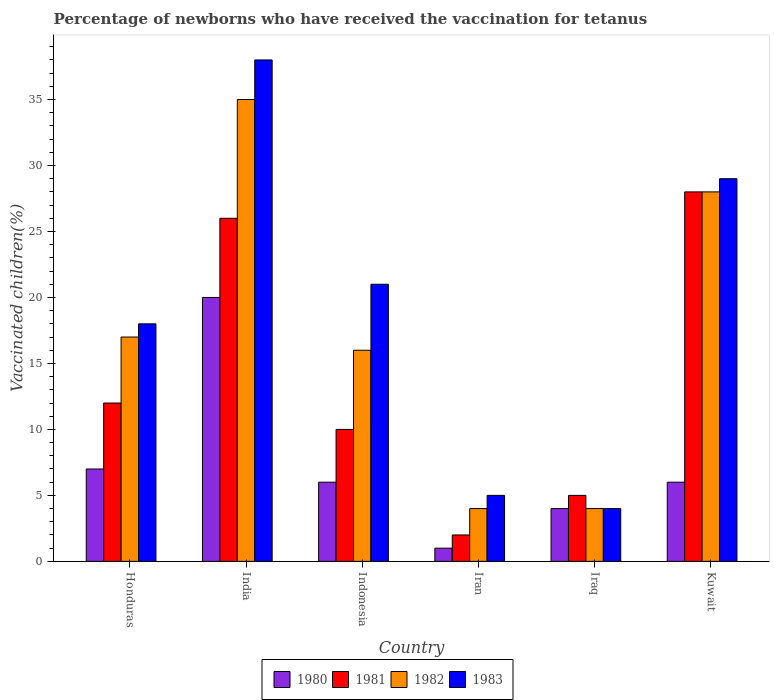Are the number of bars per tick equal to the number of legend labels?
Ensure brevity in your answer.  Yes. What is the label of the 6th group of bars from the left?
Your response must be concise. Kuwait. What is the percentage of vaccinated children in 1983 in Iraq?
Your answer should be compact. 4. Across all countries, what is the minimum percentage of vaccinated children in 1981?
Ensure brevity in your answer.  2. In which country was the percentage of vaccinated children in 1982 maximum?
Your response must be concise. India. In which country was the percentage of vaccinated children in 1980 minimum?
Keep it short and to the point. Iran. What is the total percentage of vaccinated children in 1982 in the graph?
Ensure brevity in your answer.  104. What is the difference between the percentage of vaccinated children in 1982 in Honduras and that in Iraq?
Provide a succinct answer. 13. What is the average percentage of vaccinated children in 1983 per country?
Offer a terse response. 19.17. What is the difference between the percentage of vaccinated children of/in 1982 and percentage of vaccinated children of/in 1981 in Honduras?
Ensure brevity in your answer.  5. In how many countries, is the percentage of vaccinated children in 1983 greater than 17 %?
Ensure brevity in your answer.  4. What is the ratio of the percentage of vaccinated children in 1982 in Iraq to that in Kuwait?
Your answer should be very brief. 0.14. Is the difference between the percentage of vaccinated children in 1982 in Honduras and Kuwait greater than the difference between the percentage of vaccinated children in 1981 in Honduras and Kuwait?
Provide a succinct answer. Yes. What is the difference between the highest and the lowest percentage of vaccinated children in 1983?
Provide a short and direct response. 34. In how many countries, is the percentage of vaccinated children in 1981 greater than the average percentage of vaccinated children in 1981 taken over all countries?
Your answer should be compact. 2. Is it the case that in every country, the sum of the percentage of vaccinated children in 1981 and percentage of vaccinated children in 1983 is greater than the percentage of vaccinated children in 1980?
Your response must be concise. Yes. How many bars are there?
Provide a short and direct response. 24. What is the difference between two consecutive major ticks on the Y-axis?
Offer a terse response. 5. Are the values on the major ticks of Y-axis written in scientific E-notation?
Offer a very short reply. No. What is the title of the graph?
Offer a terse response. Percentage of newborns who have received the vaccination for tetanus. What is the label or title of the Y-axis?
Ensure brevity in your answer.  Vaccinated children(%). What is the Vaccinated children(%) in 1980 in Honduras?
Offer a very short reply. 7. What is the Vaccinated children(%) of 1981 in Honduras?
Provide a succinct answer. 12. What is the Vaccinated children(%) of 1980 in India?
Keep it short and to the point. 20. What is the Vaccinated children(%) in 1980 in Indonesia?
Offer a very short reply. 6. What is the Vaccinated children(%) of 1982 in Indonesia?
Provide a succinct answer. 16. What is the Vaccinated children(%) in 1981 in Iran?
Your answer should be compact. 2. What is the Vaccinated children(%) in 1982 in Iran?
Ensure brevity in your answer.  4. What is the Vaccinated children(%) in 1983 in Iran?
Your response must be concise. 5. What is the Vaccinated children(%) of 1981 in Iraq?
Make the answer very short. 5. What is the Vaccinated children(%) of 1981 in Kuwait?
Make the answer very short. 28. What is the Vaccinated children(%) in 1983 in Kuwait?
Make the answer very short. 29. Across all countries, what is the maximum Vaccinated children(%) in 1980?
Provide a succinct answer. 20. Across all countries, what is the maximum Vaccinated children(%) in 1982?
Offer a terse response. 35. Across all countries, what is the minimum Vaccinated children(%) of 1980?
Your response must be concise. 1. Across all countries, what is the minimum Vaccinated children(%) in 1981?
Your answer should be compact. 2. Across all countries, what is the minimum Vaccinated children(%) of 1983?
Your response must be concise. 4. What is the total Vaccinated children(%) in 1981 in the graph?
Give a very brief answer. 83. What is the total Vaccinated children(%) in 1982 in the graph?
Keep it short and to the point. 104. What is the total Vaccinated children(%) in 1983 in the graph?
Your answer should be very brief. 115. What is the difference between the Vaccinated children(%) in 1981 in Honduras and that in India?
Keep it short and to the point. -14. What is the difference between the Vaccinated children(%) in 1982 in Honduras and that in Indonesia?
Make the answer very short. 1. What is the difference between the Vaccinated children(%) in 1981 in Honduras and that in Iran?
Your answer should be very brief. 10. What is the difference between the Vaccinated children(%) of 1982 in Honduras and that in Iran?
Your answer should be compact. 13. What is the difference between the Vaccinated children(%) of 1980 in Honduras and that in Iraq?
Offer a very short reply. 3. What is the difference between the Vaccinated children(%) of 1981 in Honduras and that in Iraq?
Keep it short and to the point. 7. What is the difference between the Vaccinated children(%) of 1982 in Honduras and that in Iraq?
Offer a very short reply. 13. What is the difference between the Vaccinated children(%) of 1983 in Honduras and that in Iraq?
Ensure brevity in your answer.  14. What is the difference between the Vaccinated children(%) of 1982 in Honduras and that in Kuwait?
Offer a very short reply. -11. What is the difference between the Vaccinated children(%) in 1980 in India and that in Indonesia?
Your response must be concise. 14. What is the difference between the Vaccinated children(%) in 1981 in India and that in Indonesia?
Offer a very short reply. 16. What is the difference between the Vaccinated children(%) of 1980 in India and that in Iran?
Your answer should be compact. 19. What is the difference between the Vaccinated children(%) in 1981 in India and that in Iran?
Your response must be concise. 24. What is the difference between the Vaccinated children(%) in 1983 in India and that in Iran?
Give a very brief answer. 33. What is the difference between the Vaccinated children(%) of 1980 in India and that in Iraq?
Offer a terse response. 16. What is the difference between the Vaccinated children(%) in 1982 in India and that in Iraq?
Your response must be concise. 31. What is the difference between the Vaccinated children(%) of 1983 in India and that in Iraq?
Your response must be concise. 34. What is the difference between the Vaccinated children(%) in 1980 in India and that in Kuwait?
Your answer should be very brief. 14. What is the difference between the Vaccinated children(%) of 1981 in India and that in Kuwait?
Your answer should be very brief. -2. What is the difference between the Vaccinated children(%) of 1983 in Indonesia and that in Iraq?
Keep it short and to the point. 17. What is the difference between the Vaccinated children(%) of 1981 in Indonesia and that in Kuwait?
Provide a short and direct response. -18. What is the difference between the Vaccinated children(%) in 1983 in Indonesia and that in Kuwait?
Offer a terse response. -8. What is the difference between the Vaccinated children(%) of 1980 in Iran and that in Iraq?
Make the answer very short. -3. What is the difference between the Vaccinated children(%) in 1983 in Iran and that in Iraq?
Offer a very short reply. 1. What is the difference between the Vaccinated children(%) in 1982 in Iran and that in Kuwait?
Your answer should be very brief. -24. What is the difference between the Vaccinated children(%) in 1983 in Iran and that in Kuwait?
Ensure brevity in your answer.  -24. What is the difference between the Vaccinated children(%) of 1980 in Iraq and that in Kuwait?
Your response must be concise. -2. What is the difference between the Vaccinated children(%) of 1982 in Iraq and that in Kuwait?
Provide a succinct answer. -24. What is the difference between the Vaccinated children(%) in 1983 in Iraq and that in Kuwait?
Give a very brief answer. -25. What is the difference between the Vaccinated children(%) of 1980 in Honduras and the Vaccinated children(%) of 1982 in India?
Give a very brief answer. -28. What is the difference between the Vaccinated children(%) of 1980 in Honduras and the Vaccinated children(%) of 1983 in India?
Give a very brief answer. -31. What is the difference between the Vaccinated children(%) in 1981 in Honduras and the Vaccinated children(%) in 1983 in India?
Ensure brevity in your answer.  -26. What is the difference between the Vaccinated children(%) in 1982 in Honduras and the Vaccinated children(%) in 1983 in India?
Ensure brevity in your answer.  -21. What is the difference between the Vaccinated children(%) in 1980 in Honduras and the Vaccinated children(%) in 1981 in Indonesia?
Provide a succinct answer. -3. What is the difference between the Vaccinated children(%) in 1980 in Honduras and the Vaccinated children(%) in 1982 in Indonesia?
Offer a very short reply. -9. What is the difference between the Vaccinated children(%) in 1981 in Honduras and the Vaccinated children(%) in 1982 in Indonesia?
Ensure brevity in your answer.  -4. What is the difference between the Vaccinated children(%) in 1981 in Honduras and the Vaccinated children(%) in 1983 in Indonesia?
Your answer should be very brief. -9. What is the difference between the Vaccinated children(%) of 1982 in Honduras and the Vaccinated children(%) of 1983 in Indonesia?
Offer a terse response. -4. What is the difference between the Vaccinated children(%) in 1980 in Honduras and the Vaccinated children(%) in 1983 in Iran?
Provide a succinct answer. 2. What is the difference between the Vaccinated children(%) in 1980 in Honduras and the Vaccinated children(%) in 1981 in Iraq?
Your answer should be compact. 2. What is the difference between the Vaccinated children(%) in 1981 in Honduras and the Vaccinated children(%) in 1982 in Iraq?
Provide a short and direct response. 8. What is the difference between the Vaccinated children(%) of 1981 in Honduras and the Vaccinated children(%) of 1983 in Iraq?
Your response must be concise. 8. What is the difference between the Vaccinated children(%) in 1982 in Honduras and the Vaccinated children(%) in 1983 in Kuwait?
Keep it short and to the point. -12. What is the difference between the Vaccinated children(%) in 1980 in India and the Vaccinated children(%) in 1981 in Indonesia?
Make the answer very short. 10. What is the difference between the Vaccinated children(%) in 1981 in India and the Vaccinated children(%) in 1983 in Indonesia?
Offer a very short reply. 5. What is the difference between the Vaccinated children(%) in 1980 in India and the Vaccinated children(%) in 1982 in Iran?
Your answer should be very brief. 16. What is the difference between the Vaccinated children(%) of 1980 in India and the Vaccinated children(%) of 1983 in Iran?
Your answer should be compact. 15. What is the difference between the Vaccinated children(%) in 1981 in India and the Vaccinated children(%) in 1982 in Iran?
Your response must be concise. 22. What is the difference between the Vaccinated children(%) in 1980 in India and the Vaccinated children(%) in 1981 in Iraq?
Offer a terse response. 15. What is the difference between the Vaccinated children(%) of 1980 in India and the Vaccinated children(%) of 1982 in Iraq?
Make the answer very short. 16. What is the difference between the Vaccinated children(%) of 1981 in India and the Vaccinated children(%) of 1983 in Iraq?
Keep it short and to the point. 22. What is the difference between the Vaccinated children(%) in 1980 in India and the Vaccinated children(%) in 1981 in Kuwait?
Keep it short and to the point. -8. What is the difference between the Vaccinated children(%) in 1980 in India and the Vaccinated children(%) in 1983 in Kuwait?
Your answer should be very brief. -9. What is the difference between the Vaccinated children(%) of 1981 in India and the Vaccinated children(%) of 1982 in Kuwait?
Offer a terse response. -2. What is the difference between the Vaccinated children(%) of 1981 in India and the Vaccinated children(%) of 1983 in Kuwait?
Your answer should be very brief. -3. What is the difference between the Vaccinated children(%) in 1982 in India and the Vaccinated children(%) in 1983 in Kuwait?
Give a very brief answer. 6. What is the difference between the Vaccinated children(%) of 1980 in Indonesia and the Vaccinated children(%) of 1982 in Iran?
Provide a short and direct response. 2. What is the difference between the Vaccinated children(%) in 1980 in Indonesia and the Vaccinated children(%) in 1983 in Iran?
Your answer should be very brief. 1. What is the difference between the Vaccinated children(%) in 1981 in Indonesia and the Vaccinated children(%) in 1982 in Iran?
Your answer should be very brief. 6. What is the difference between the Vaccinated children(%) in 1980 in Indonesia and the Vaccinated children(%) in 1982 in Iraq?
Keep it short and to the point. 2. What is the difference between the Vaccinated children(%) in 1981 in Indonesia and the Vaccinated children(%) in 1982 in Iraq?
Give a very brief answer. 6. What is the difference between the Vaccinated children(%) in 1981 in Indonesia and the Vaccinated children(%) in 1983 in Iraq?
Offer a terse response. 6. What is the difference between the Vaccinated children(%) in 1980 in Indonesia and the Vaccinated children(%) in 1982 in Kuwait?
Provide a short and direct response. -22. What is the difference between the Vaccinated children(%) of 1980 in Indonesia and the Vaccinated children(%) of 1983 in Kuwait?
Offer a terse response. -23. What is the difference between the Vaccinated children(%) in 1982 in Indonesia and the Vaccinated children(%) in 1983 in Kuwait?
Your answer should be compact. -13. What is the difference between the Vaccinated children(%) in 1980 in Iran and the Vaccinated children(%) in 1983 in Iraq?
Ensure brevity in your answer.  -3. What is the difference between the Vaccinated children(%) in 1981 in Iran and the Vaccinated children(%) in 1982 in Iraq?
Ensure brevity in your answer.  -2. What is the difference between the Vaccinated children(%) of 1980 in Iran and the Vaccinated children(%) of 1983 in Kuwait?
Offer a very short reply. -28. What is the difference between the Vaccinated children(%) of 1981 in Iran and the Vaccinated children(%) of 1982 in Kuwait?
Your answer should be compact. -26. What is the difference between the Vaccinated children(%) in 1981 in Iran and the Vaccinated children(%) in 1983 in Kuwait?
Offer a terse response. -27. What is the difference between the Vaccinated children(%) in 1980 in Iraq and the Vaccinated children(%) in 1981 in Kuwait?
Your answer should be compact. -24. What is the difference between the Vaccinated children(%) of 1981 in Iraq and the Vaccinated children(%) of 1982 in Kuwait?
Provide a short and direct response. -23. What is the difference between the Vaccinated children(%) in 1982 in Iraq and the Vaccinated children(%) in 1983 in Kuwait?
Your response must be concise. -25. What is the average Vaccinated children(%) in 1980 per country?
Ensure brevity in your answer.  7.33. What is the average Vaccinated children(%) of 1981 per country?
Offer a terse response. 13.83. What is the average Vaccinated children(%) in 1982 per country?
Provide a succinct answer. 17.33. What is the average Vaccinated children(%) in 1983 per country?
Provide a succinct answer. 19.17. What is the difference between the Vaccinated children(%) in 1980 and Vaccinated children(%) in 1981 in Honduras?
Your answer should be compact. -5. What is the difference between the Vaccinated children(%) in 1980 and Vaccinated children(%) in 1983 in Honduras?
Your answer should be compact. -11. What is the difference between the Vaccinated children(%) of 1981 and Vaccinated children(%) of 1983 in Honduras?
Your answer should be very brief. -6. What is the difference between the Vaccinated children(%) of 1980 and Vaccinated children(%) of 1981 in India?
Keep it short and to the point. -6. What is the difference between the Vaccinated children(%) in 1980 and Vaccinated children(%) in 1982 in India?
Your answer should be compact. -15. What is the difference between the Vaccinated children(%) of 1980 and Vaccinated children(%) of 1983 in India?
Make the answer very short. -18. What is the difference between the Vaccinated children(%) in 1981 and Vaccinated children(%) in 1983 in India?
Give a very brief answer. -12. What is the difference between the Vaccinated children(%) of 1980 and Vaccinated children(%) of 1981 in Indonesia?
Your answer should be very brief. -4. What is the difference between the Vaccinated children(%) in 1980 and Vaccinated children(%) in 1983 in Indonesia?
Give a very brief answer. -15. What is the difference between the Vaccinated children(%) in 1981 and Vaccinated children(%) in 1983 in Indonesia?
Your response must be concise. -11. What is the difference between the Vaccinated children(%) in 1982 and Vaccinated children(%) in 1983 in Indonesia?
Your answer should be very brief. -5. What is the difference between the Vaccinated children(%) in 1980 and Vaccinated children(%) in 1983 in Iran?
Offer a terse response. -4. What is the difference between the Vaccinated children(%) of 1981 and Vaccinated children(%) of 1982 in Iran?
Give a very brief answer. -2. What is the difference between the Vaccinated children(%) of 1980 and Vaccinated children(%) of 1983 in Iraq?
Make the answer very short. 0. What is the difference between the Vaccinated children(%) of 1980 and Vaccinated children(%) of 1981 in Kuwait?
Make the answer very short. -22. What is the difference between the Vaccinated children(%) in 1980 and Vaccinated children(%) in 1982 in Kuwait?
Your answer should be very brief. -22. What is the difference between the Vaccinated children(%) in 1980 and Vaccinated children(%) in 1983 in Kuwait?
Give a very brief answer. -23. What is the difference between the Vaccinated children(%) in 1981 and Vaccinated children(%) in 1982 in Kuwait?
Your answer should be compact. 0. What is the difference between the Vaccinated children(%) of 1981 and Vaccinated children(%) of 1983 in Kuwait?
Your answer should be compact. -1. What is the ratio of the Vaccinated children(%) of 1980 in Honduras to that in India?
Provide a succinct answer. 0.35. What is the ratio of the Vaccinated children(%) in 1981 in Honduras to that in India?
Offer a very short reply. 0.46. What is the ratio of the Vaccinated children(%) of 1982 in Honduras to that in India?
Ensure brevity in your answer.  0.49. What is the ratio of the Vaccinated children(%) of 1983 in Honduras to that in India?
Provide a succinct answer. 0.47. What is the ratio of the Vaccinated children(%) in 1980 in Honduras to that in Indonesia?
Your answer should be compact. 1.17. What is the ratio of the Vaccinated children(%) of 1982 in Honduras to that in Indonesia?
Ensure brevity in your answer.  1.06. What is the ratio of the Vaccinated children(%) in 1983 in Honduras to that in Indonesia?
Offer a very short reply. 0.86. What is the ratio of the Vaccinated children(%) in 1981 in Honduras to that in Iran?
Offer a terse response. 6. What is the ratio of the Vaccinated children(%) in 1982 in Honduras to that in Iran?
Ensure brevity in your answer.  4.25. What is the ratio of the Vaccinated children(%) in 1980 in Honduras to that in Iraq?
Your answer should be very brief. 1.75. What is the ratio of the Vaccinated children(%) in 1982 in Honduras to that in Iraq?
Provide a short and direct response. 4.25. What is the ratio of the Vaccinated children(%) in 1983 in Honduras to that in Iraq?
Offer a very short reply. 4.5. What is the ratio of the Vaccinated children(%) in 1980 in Honduras to that in Kuwait?
Your response must be concise. 1.17. What is the ratio of the Vaccinated children(%) in 1981 in Honduras to that in Kuwait?
Your response must be concise. 0.43. What is the ratio of the Vaccinated children(%) in 1982 in Honduras to that in Kuwait?
Give a very brief answer. 0.61. What is the ratio of the Vaccinated children(%) of 1983 in Honduras to that in Kuwait?
Provide a succinct answer. 0.62. What is the ratio of the Vaccinated children(%) of 1980 in India to that in Indonesia?
Provide a short and direct response. 3.33. What is the ratio of the Vaccinated children(%) in 1981 in India to that in Indonesia?
Offer a terse response. 2.6. What is the ratio of the Vaccinated children(%) of 1982 in India to that in Indonesia?
Make the answer very short. 2.19. What is the ratio of the Vaccinated children(%) of 1983 in India to that in Indonesia?
Make the answer very short. 1.81. What is the ratio of the Vaccinated children(%) in 1981 in India to that in Iran?
Your response must be concise. 13. What is the ratio of the Vaccinated children(%) in 1982 in India to that in Iran?
Offer a very short reply. 8.75. What is the ratio of the Vaccinated children(%) of 1981 in India to that in Iraq?
Offer a terse response. 5.2. What is the ratio of the Vaccinated children(%) in 1982 in India to that in Iraq?
Make the answer very short. 8.75. What is the ratio of the Vaccinated children(%) of 1983 in India to that in Iraq?
Provide a succinct answer. 9.5. What is the ratio of the Vaccinated children(%) of 1983 in India to that in Kuwait?
Offer a very short reply. 1.31. What is the ratio of the Vaccinated children(%) in 1981 in Indonesia to that in Iran?
Offer a very short reply. 5. What is the ratio of the Vaccinated children(%) of 1983 in Indonesia to that in Iran?
Your answer should be compact. 4.2. What is the ratio of the Vaccinated children(%) in 1980 in Indonesia to that in Iraq?
Provide a short and direct response. 1.5. What is the ratio of the Vaccinated children(%) of 1981 in Indonesia to that in Iraq?
Provide a succinct answer. 2. What is the ratio of the Vaccinated children(%) in 1983 in Indonesia to that in Iraq?
Your answer should be very brief. 5.25. What is the ratio of the Vaccinated children(%) in 1980 in Indonesia to that in Kuwait?
Offer a terse response. 1. What is the ratio of the Vaccinated children(%) of 1981 in Indonesia to that in Kuwait?
Your response must be concise. 0.36. What is the ratio of the Vaccinated children(%) in 1982 in Indonesia to that in Kuwait?
Provide a succinct answer. 0.57. What is the ratio of the Vaccinated children(%) of 1983 in Indonesia to that in Kuwait?
Ensure brevity in your answer.  0.72. What is the ratio of the Vaccinated children(%) of 1982 in Iran to that in Iraq?
Offer a very short reply. 1. What is the ratio of the Vaccinated children(%) of 1981 in Iran to that in Kuwait?
Your answer should be very brief. 0.07. What is the ratio of the Vaccinated children(%) of 1982 in Iran to that in Kuwait?
Offer a very short reply. 0.14. What is the ratio of the Vaccinated children(%) in 1983 in Iran to that in Kuwait?
Make the answer very short. 0.17. What is the ratio of the Vaccinated children(%) of 1981 in Iraq to that in Kuwait?
Offer a very short reply. 0.18. What is the ratio of the Vaccinated children(%) of 1982 in Iraq to that in Kuwait?
Make the answer very short. 0.14. What is the ratio of the Vaccinated children(%) in 1983 in Iraq to that in Kuwait?
Keep it short and to the point. 0.14. What is the difference between the highest and the second highest Vaccinated children(%) of 1980?
Ensure brevity in your answer.  13. What is the difference between the highest and the second highest Vaccinated children(%) of 1981?
Provide a short and direct response. 2. What is the difference between the highest and the second highest Vaccinated children(%) in 1983?
Keep it short and to the point. 9. What is the difference between the highest and the lowest Vaccinated children(%) in 1980?
Ensure brevity in your answer.  19. What is the difference between the highest and the lowest Vaccinated children(%) of 1982?
Give a very brief answer. 31. What is the difference between the highest and the lowest Vaccinated children(%) of 1983?
Offer a terse response. 34. 